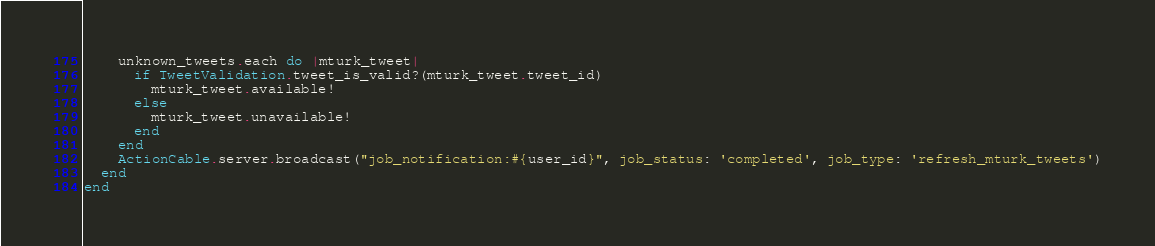Convert code to text. <code><loc_0><loc_0><loc_500><loc_500><_Ruby_>    unknown_tweets.each do |mturk_tweet|
      if TweetValidation.tweet_is_valid?(mturk_tweet.tweet_id)
        mturk_tweet.available!
      else
        mturk_tweet.unavailable!
      end
    end
    ActionCable.server.broadcast("job_notification:#{user_id}", job_status: 'completed', job_type: 'refresh_mturk_tweets')
  end
end
</code> 